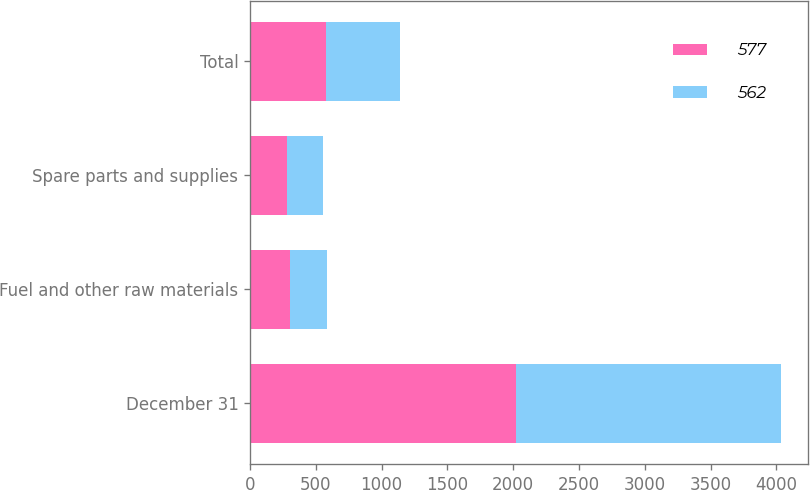Convert chart to OTSL. <chart><loc_0><loc_0><loc_500><loc_500><stacked_bar_chart><ecel><fcel>December 31<fcel>Fuel and other raw materials<fcel>Spare parts and supplies<fcel>Total<nl><fcel>577<fcel>2018<fcel>300<fcel>277<fcel>577<nl><fcel>562<fcel>2017<fcel>284<fcel>278<fcel>562<nl></chart> 